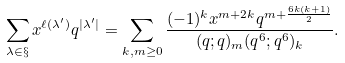<formula> <loc_0><loc_0><loc_500><loc_500>\sum _ { \lambda \in \S } x ^ { \ell ( \lambda ^ { \prime } ) } q ^ { | \lambda ^ { \prime } | } = \sum _ { k , m \geq 0 } \frac { ( - 1 ) ^ { k } x ^ { m + 2 k } q ^ { m + \frac { 6 k ( k + 1 ) } { 2 } } } { ( q ; q ) _ { m } ( q ^ { 6 } ; q ^ { 6 } ) _ { k } } .</formula> 